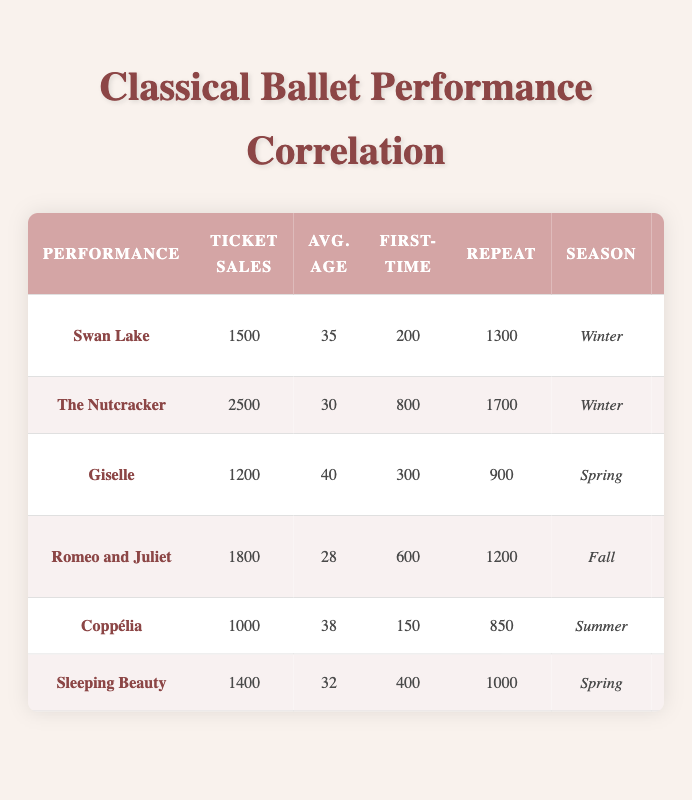What is the ticket sales for "The Nutcracker"? The table provides a direct value for ticket sales associated with "The Nutcracker," which is listed as 2500.
Answer: 2500 How many first-time attendees did "Swan Lake" have? The value for first-time attendees for "Swan Lake" is directly noted in the table as 200.
Answer: 200 Which performance had the highest average audience age? By comparing the average audience ages across all performances, "Giselle" shows the highest average at 40, based on its corresponding row in the table.
Answer: Giselle What is the total number of repeat attendees across all performances? To find the total, we sum the repeat attendees: 1300 (Swan Lake) + 1700 (The Nutcracker) + 900 (Giselle) + 1200 (Romeo and Juliet) + 850 (Coppélia) + 1000 (Sleeping Beauty) = 6150.
Answer: 6150 Do "Coppélia" and "Sleeping Beauty" both take place in the Spring season? Referring to the season information in the table, "Coppélia" is in Summer and "Sleeping Beauty" is in Spring. Therefore, the statement is false.
Answer: No Is the number of first-time attendees for "Romeo and Juliet" more than the number of first-time attendees for "Swan Lake"? The table shows that "Romeo and Juliet" had 600 first-time attendees while "Swan Lake" had 200. Since 600 is greater than 200, the statement is true.
Answer: Yes Which showcase city had the lowest ticket sales? By examining the ticket sales, we find the lowest figure belongs to "Coppélia," with 1000 in Miami. This is determined by checking all listed ticket sales.
Answer: Miami What is the difference in ticket sales between "The Nutcracker" and "Giselle"? To find the difference, subtract the ticket sales of "Giselle" from that of "The Nutcracker": 2500 - 1200 = 1300.
Answer: 1300 If the average age of attendees for "Romeo and Juliet" is 28, what would be the average age if this performance had the same average age as "The Nutcracker"? The average age for "The Nutcracker" is 30. The question implies a hypothetical scenario where the average age for "Romeo and Juliet" equals that of "The Nutcracker." Thus, the new average age would be stated as 30.
Answer: 30 